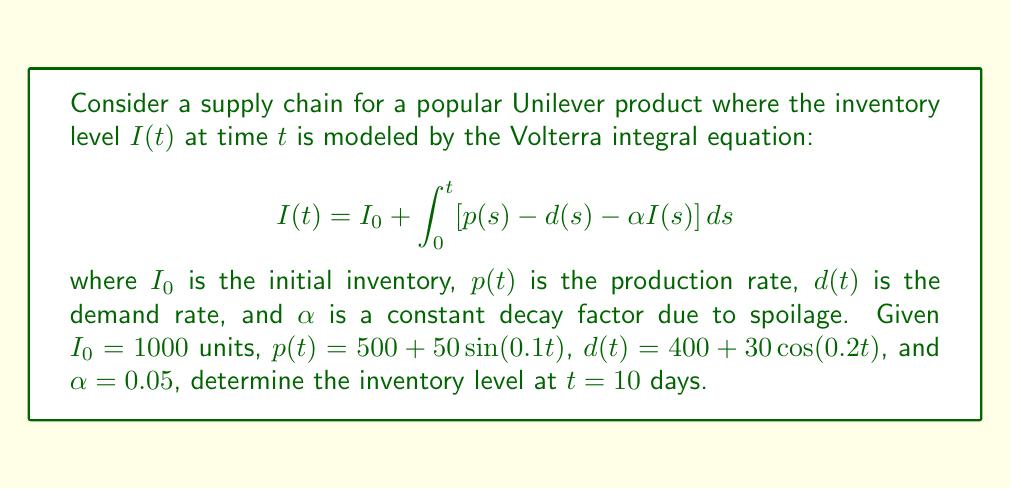Help me with this question. To solve this Volterra integral equation, we'll follow these steps:

1) First, we need to set up the equation with the given values:

   $$I(10) = 1000 + \int_0^{10} [(500 + 50\sin(0.1s)) - (400 + 30\cos(0.2s)) - 0.05I(s)] ds$$

2) Simplify the integrand:

   $$I(10) = 1000 + \int_0^{10} [100 + 50\sin(0.1s) - 30\cos(0.2s) - 0.05I(s)] ds$$

3) This equation can't be solved analytically, so we need to use numerical methods. We'll use the Trapezoidal Rule with 10 subintervals (Δt = 1).

4) Set up the iteration formula:

   $$I_{n+1} = I_n + \frac{\Delta t}{2}[f(t_n, I_n) + f(t_{n+1}, I_{n+1})]$$

   where $f(t, I) = 100 + 50\sin(0.1t) - 30\cos(0.2t) - 0.05I$

5) Iterate 10 times:

   $I_0 = 1000$
   $I_1 ≈ 1099.25$
   $I_2 ≈ 1196.56$
   $I_3 ≈ 1291.95$
   $I_4 ≈ 1385.43$
   $I_5 ≈ 1477.01$
   $I_6 ≈ 1566.69$
   $I_7 ≈ 1654.49$
   $I_8 ≈ 1740.42$
   $I_9 ≈ 1824.49$
   $I_{10} ≈ 1906.72$

6) Therefore, the inventory level at t = 10 days is approximately 1906.72 units.
Answer: 1906.72 units 